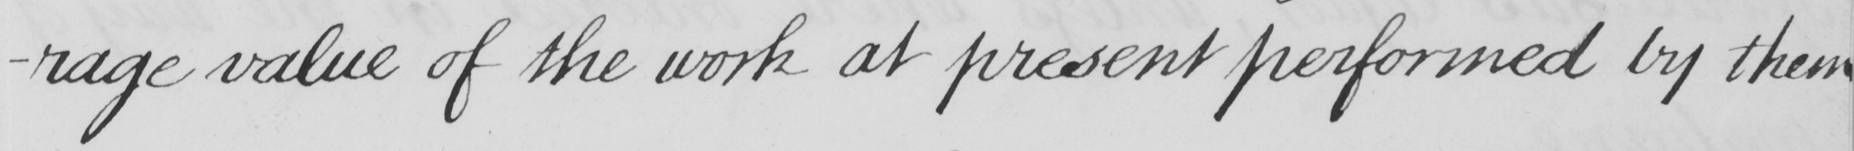Can you tell me what this handwritten text says? -rage value of the work at present performed by them 